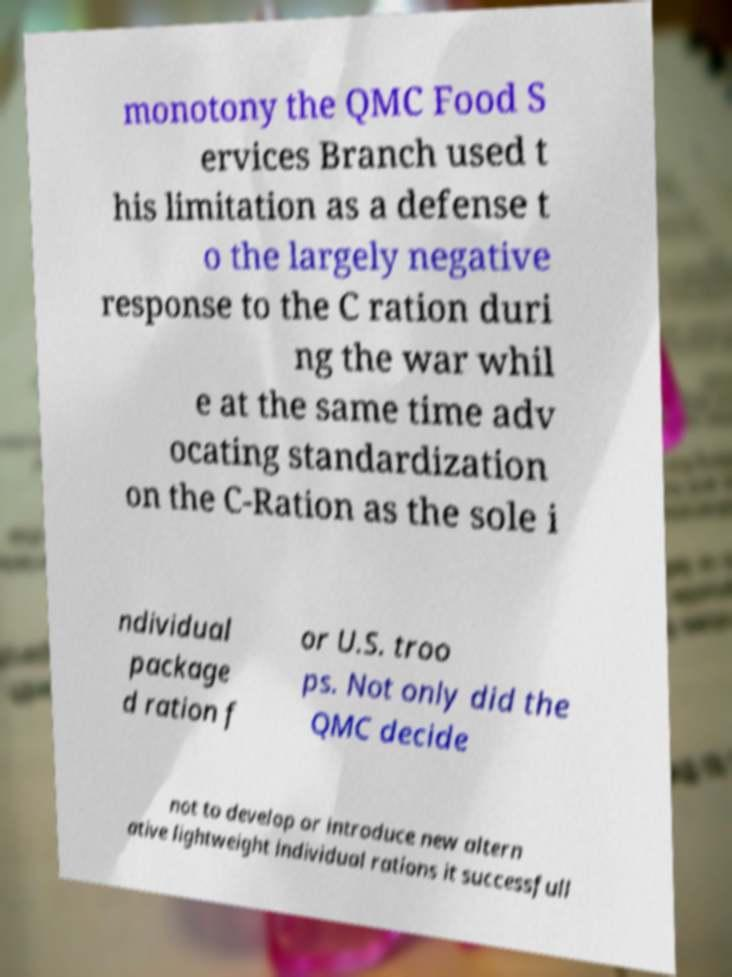I need the written content from this picture converted into text. Can you do that? monotony the QMC Food S ervices Branch used t his limitation as a defense t o the largely negative response to the C ration duri ng the war whil e at the same time adv ocating standardization on the C-Ration as the sole i ndividual package d ration f or U.S. troo ps. Not only did the QMC decide not to develop or introduce new altern ative lightweight individual rations it successfull 